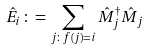Convert formula to latex. <formula><loc_0><loc_0><loc_500><loc_500>\hat { E } _ { i } \, \colon = \, \sum _ { j \colon f ( j ) = i } \hat { M } _ { j } ^ { \dag } \hat { M } _ { j }</formula> 